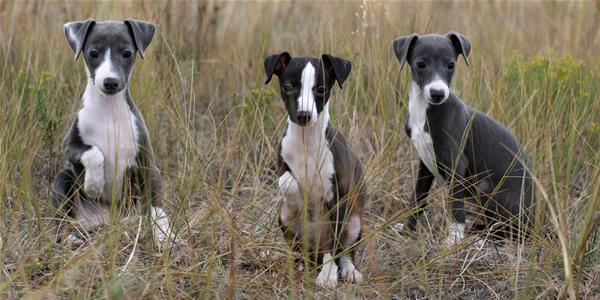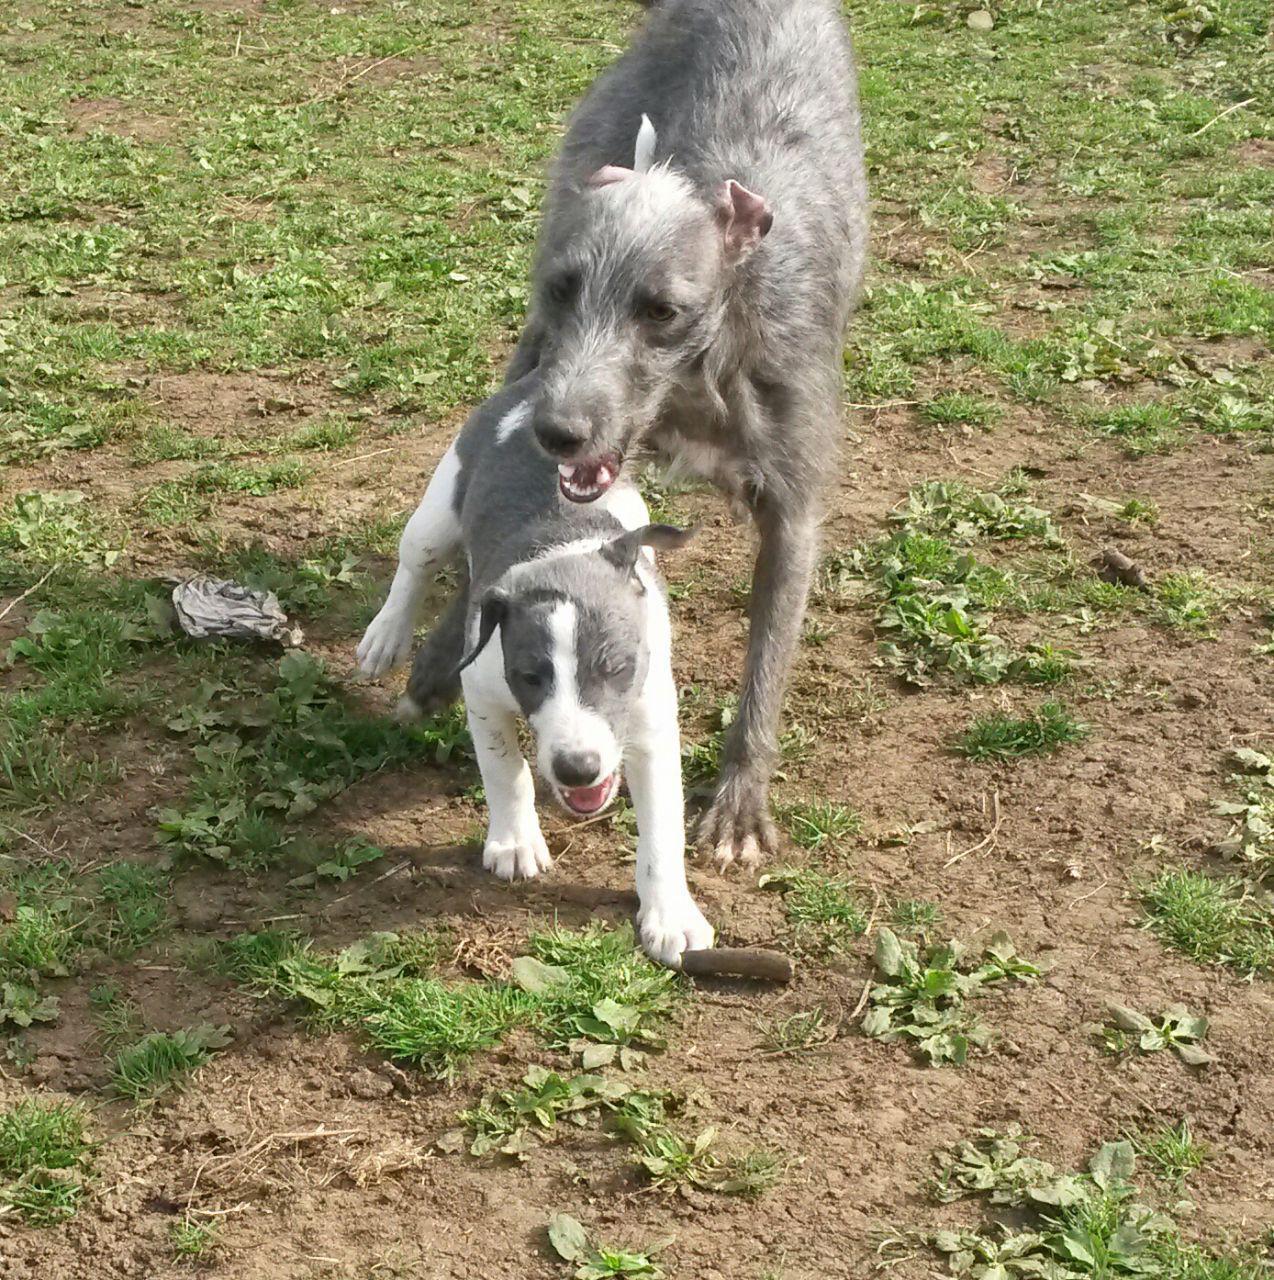The first image is the image on the left, the second image is the image on the right. Analyze the images presented: Is the assertion "One image contains only one dog, while the other image contains at least 5 dogs." valid? Answer yes or no. No. The first image is the image on the left, the second image is the image on the right. Analyze the images presented: Is the assertion "One image contains a single dog, which is looking at the camera while in a standing pose indoors." valid? Answer yes or no. No. 